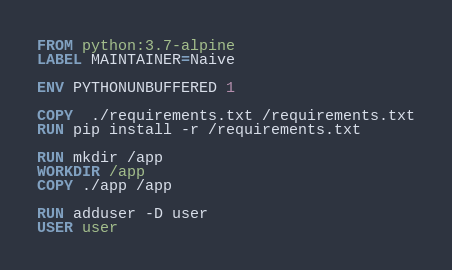Convert code to text. <code><loc_0><loc_0><loc_500><loc_500><_Dockerfile_>FROM python:3.7-alpine 
LABEL MAINTAINER=Naive

ENV PYTHONUNBUFFERED 1

COPY  ./requirements.txt /requirements.txt
RUN pip install -r /requirements.txt

RUN mkdir /app
WORKDIR /app
COPY ./app /app

RUN adduser -D user
USER user 


</code> 